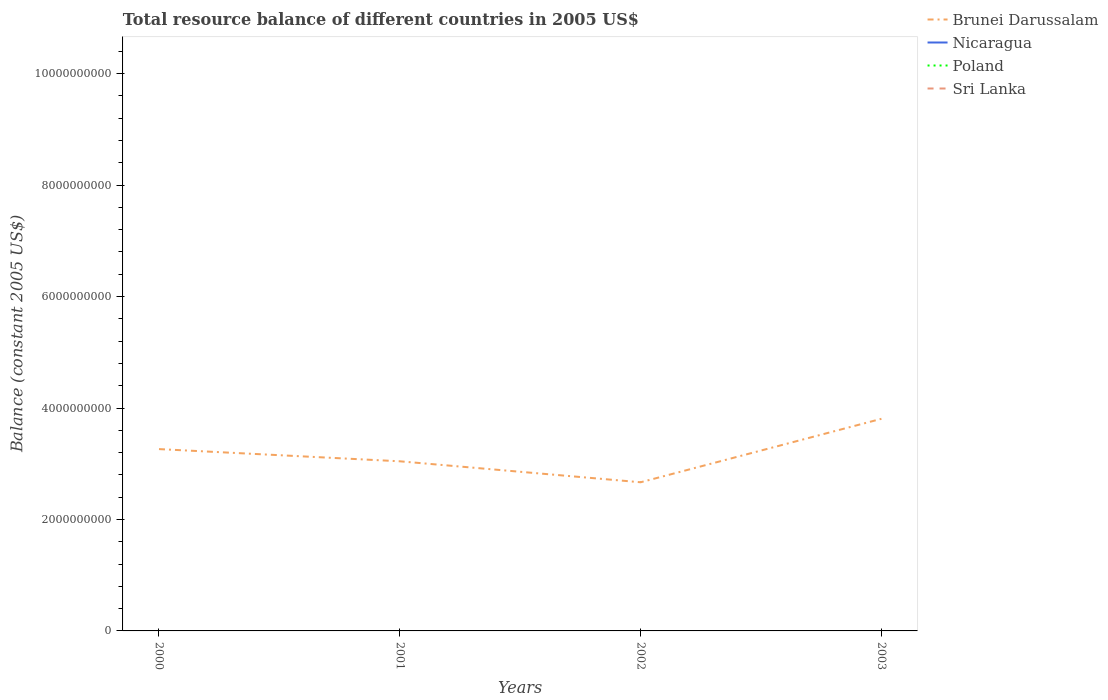What is the total total resource balance in Brunei Darussalam in the graph?
Provide a succinct answer. 5.95e+08. What is the difference between the highest and the second highest total resource balance in Brunei Darussalam?
Your answer should be very brief. 1.14e+09. What is the difference between the highest and the lowest total resource balance in Poland?
Provide a short and direct response. 0. How many lines are there?
Your answer should be compact. 1. Does the graph contain grids?
Your response must be concise. No. Where does the legend appear in the graph?
Keep it short and to the point. Top right. How are the legend labels stacked?
Provide a short and direct response. Vertical. What is the title of the graph?
Your answer should be very brief. Total resource balance of different countries in 2005 US$. Does "Mongolia" appear as one of the legend labels in the graph?
Make the answer very short. No. What is the label or title of the Y-axis?
Provide a short and direct response. Balance (constant 2005 US$). What is the Balance (constant 2005 US$) in Brunei Darussalam in 2000?
Provide a short and direct response. 3.26e+09. What is the Balance (constant 2005 US$) of Brunei Darussalam in 2001?
Offer a terse response. 3.04e+09. What is the Balance (constant 2005 US$) of Nicaragua in 2001?
Provide a succinct answer. 0. What is the Balance (constant 2005 US$) of Brunei Darussalam in 2002?
Your response must be concise. 2.67e+09. What is the Balance (constant 2005 US$) of Nicaragua in 2002?
Keep it short and to the point. 0. What is the Balance (constant 2005 US$) of Sri Lanka in 2002?
Provide a succinct answer. 0. What is the Balance (constant 2005 US$) in Brunei Darussalam in 2003?
Provide a short and direct response. 3.81e+09. What is the Balance (constant 2005 US$) of Nicaragua in 2003?
Make the answer very short. 0. Across all years, what is the maximum Balance (constant 2005 US$) in Brunei Darussalam?
Keep it short and to the point. 3.81e+09. Across all years, what is the minimum Balance (constant 2005 US$) in Brunei Darussalam?
Provide a short and direct response. 2.67e+09. What is the total Balance (constant 2005 US$) of Brunei Darussalam in the graph?
Your answer should be compact. 1.28e+1. What is the total Balance (constant 2005 US$) in Poland in the graph?
Give a very brief answer. 0. What is the difference between the Balance (constant 2005 US$) in Brunei Darussalam in 2000 and that in 2001?
Ensure brevity in your answer.  2.19e+08. What is the difference between the Balance (constant 2005 US$) of Brunei Darussalam in 2000 and that in 2002?
Your answer should be compact. 5.95e+08. What is the difference between the Balance (constant 2005 US$) of Brunei Darussalam in 2000 and that in 2003?
Your answer should be very brief. -5.44e+08. What is the difference between the Balance (constant 2005 US$) of Brunei Darussalam in 2001 and that in 2002?
Ensure brevity in your answer.  3.76e+08. What is the difference between the Balance (constant 2005 US$) of Brunei Darussalam in 2001 and that in 2003?
Your answer should be compact. -7.63e+08. What is the difference between the Balance (constant 2005 US$) of Brunei Darussalam in 2002 and that in 2003?
Ensure brevity in your answer.  -1.14e+09. What is the average Balance (constant 2005 US$) in Brunei Darussalam per year?
Your answer should be compact. 3.20e+09. What is the average Balance (constant 2005 US$) of Nicaragua per year?
Make the answer very short. 0. What is the ratio of the Balance (constant 2005 US$) in Brunei Darussalam in 2000 to that in 2001?
Your answer should be very brief. 1.07. What is the ratio of the Balance (constant 2005 US$) in Brunei Darussalam in 2000 to that in 2002?
Keep it short and to the point. 1.22. What is the ratio of the Balance (constant 2005 US$) of Brunei Darussalam in 2000 to that in 2003?
Make the answer very short. 0.86. What is the ratio of the Balance (constant 2005 US$) of Brunei Darussalam in 2001 to that in 2002?
Offer a terse response. 1.14. What is the ratio of the Balance (constant 2005 US$) of Brunei Darussalam in 2001 to that in 2003?
Make the answer very short. 0.8. What is the ratio of the Balance (constant 2005 US$) in Brunei Darussalam in 2002 to that in 2003?
Provide a short and direct response. 0.7. What is the difference between the highest and the second highest Balance (constant 2005 US$) of Brunei Darussalam?
Give a very brief answer. 5.44e+08. What is the difference between the highest and the lowest Balance (constant 2005 US$) in Brunei Darussalam?
Keep it short and to the point. 1.14e+09. 